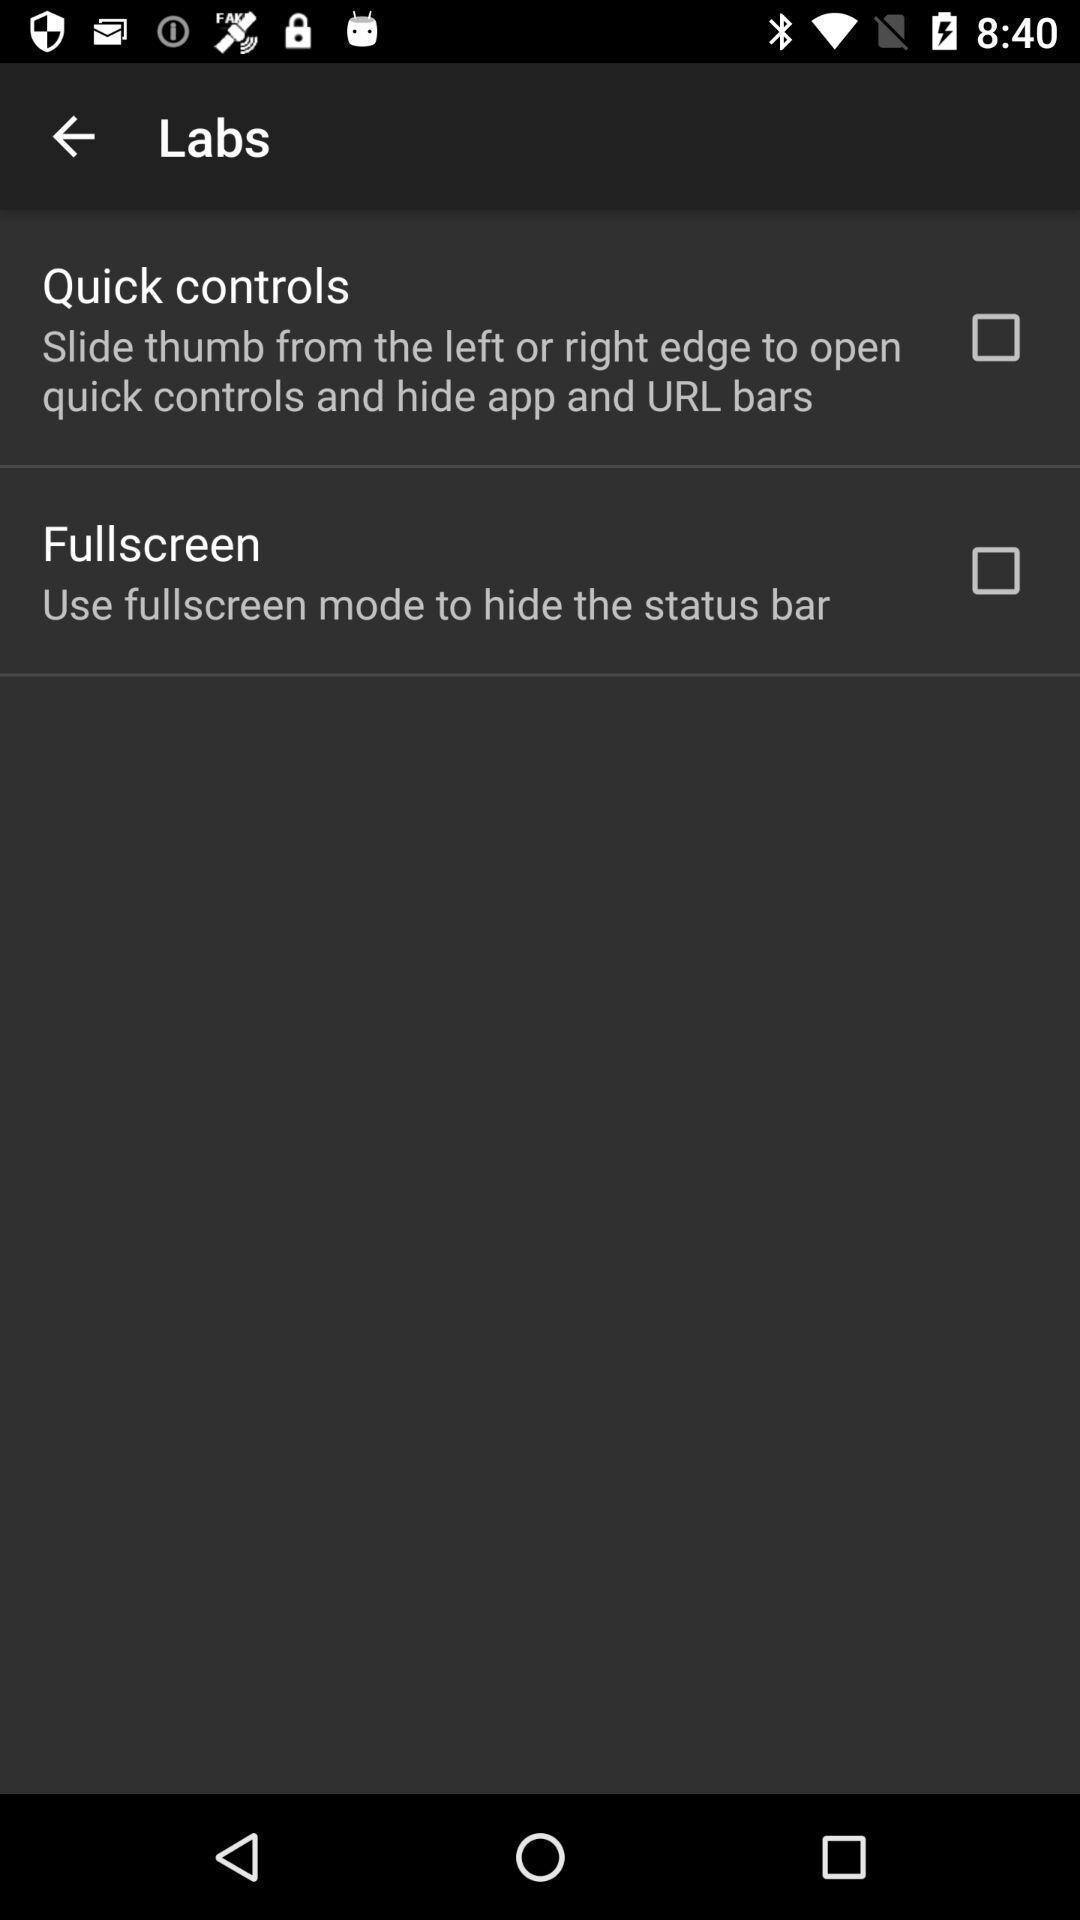Explain the elements present in this screenshot. Settings in the labs tab. 